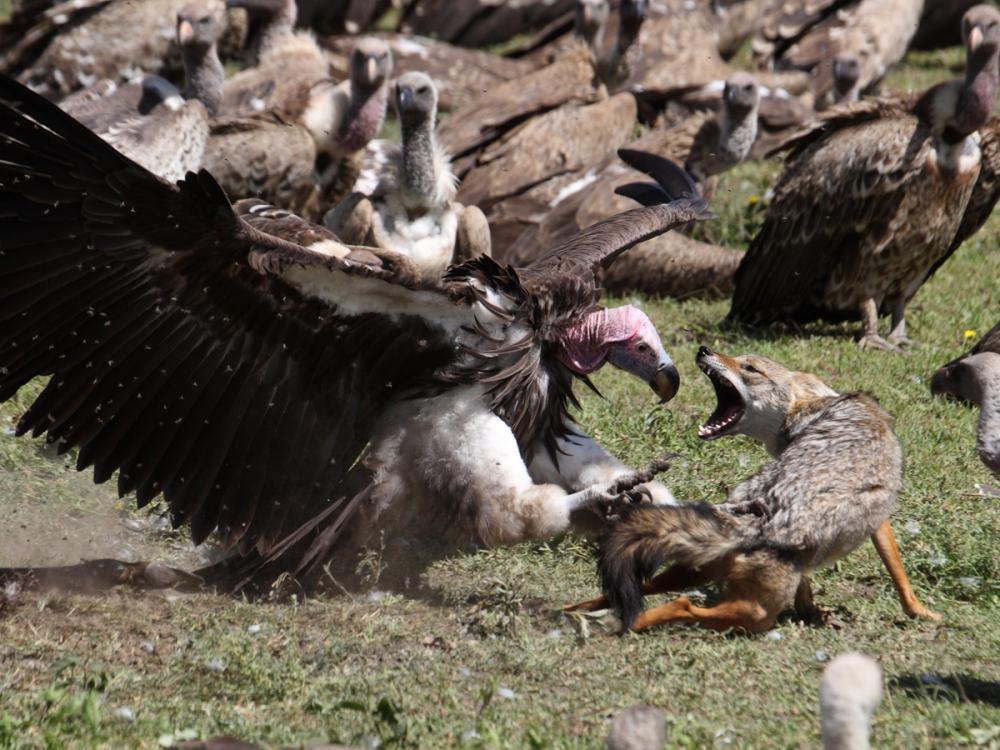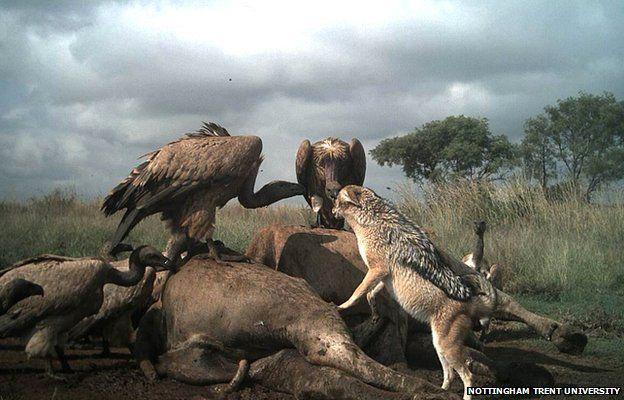The first image is the image on the left, the second image is the image on the right. For the images shown, is this caption "IN at least one image there is an hyena facing left next to a small fox,vaulters and a dead animal." true? Answer yes or no. No. The first image is the image on the left, the second image is the image on the right. For the images displayed, is the sentence "One image contains a vulture whose face is visible" factually correct? Answer yes or no. Yes. 